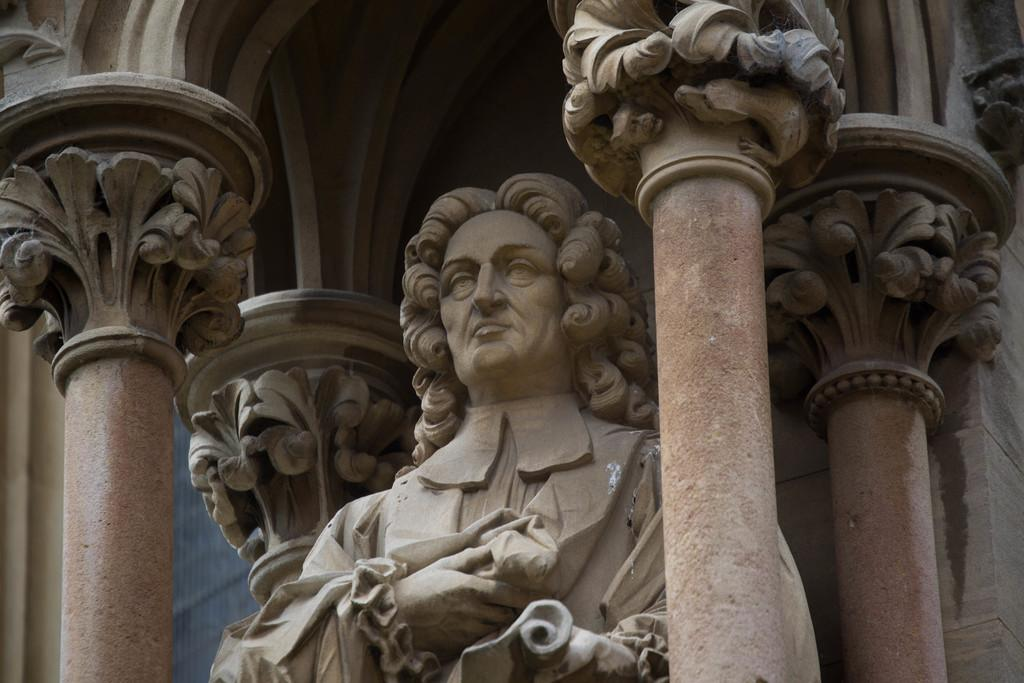What is the main subject in the middle of the image? There is a statue in the middle of the image. What other architectural features can be seen in the image? There are two pillars in the front of the image. What type of knife is the sister using for her business in the image? There is no knife, sister, or business present in the image. 